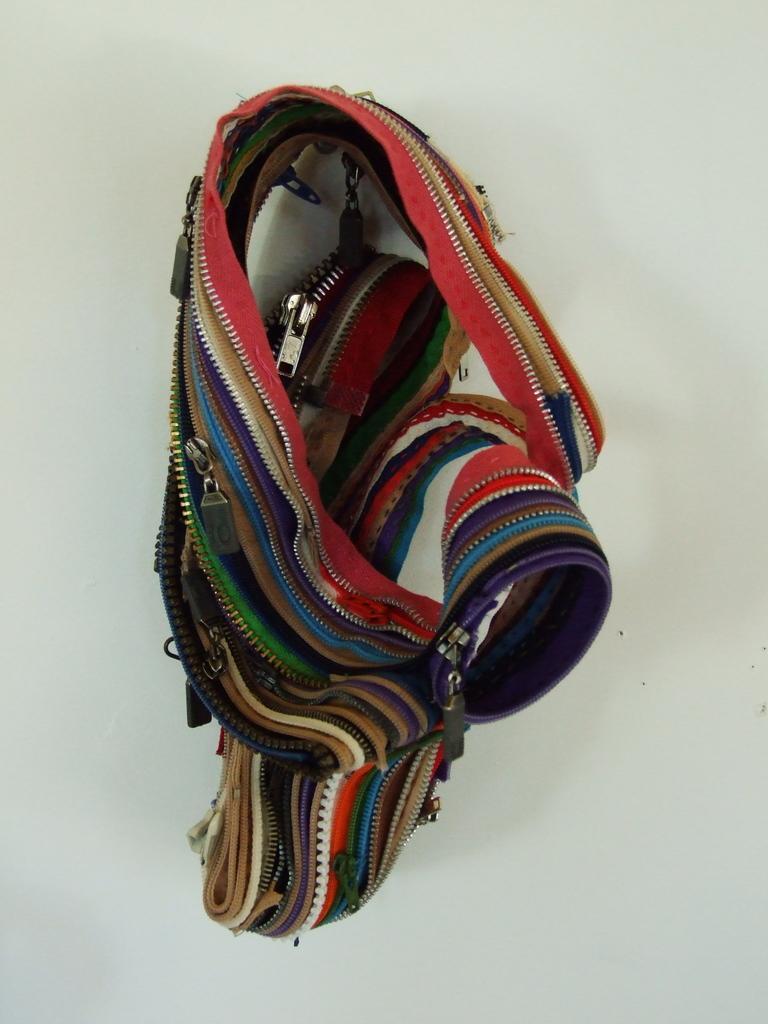Could you give a brief overview of what you see in this image? In the center of the image, we can see a belt bag on the table. 